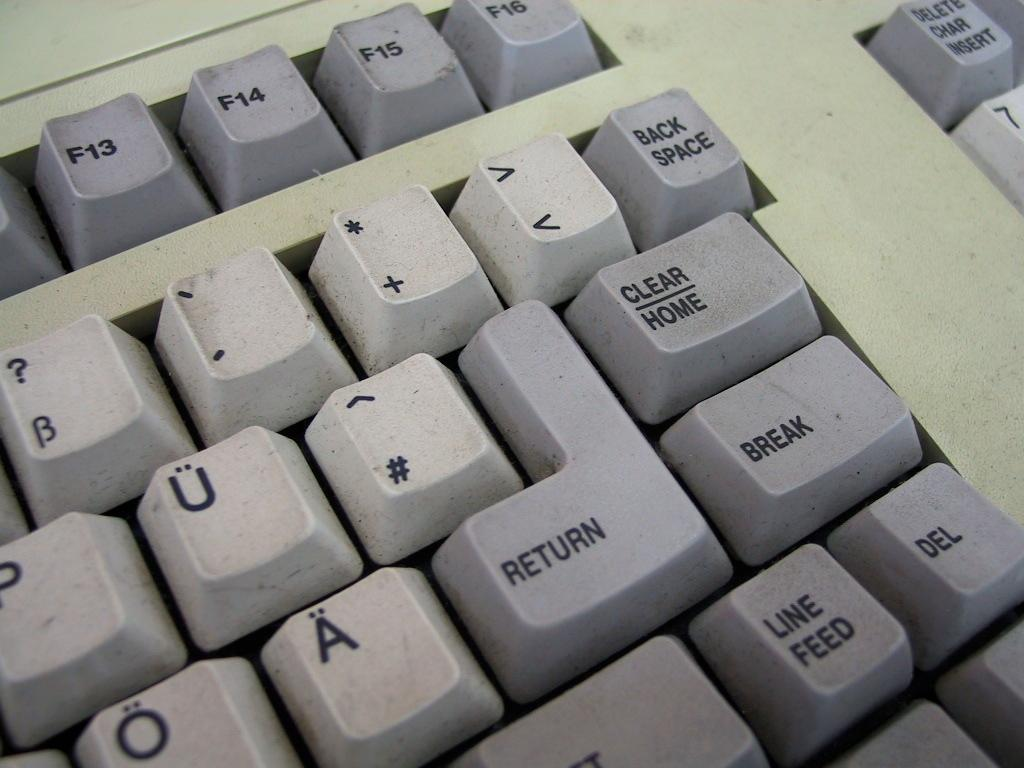<image>
Provide a brief description of the given image. A corner of a keyboard is showing the return key and the break key. 